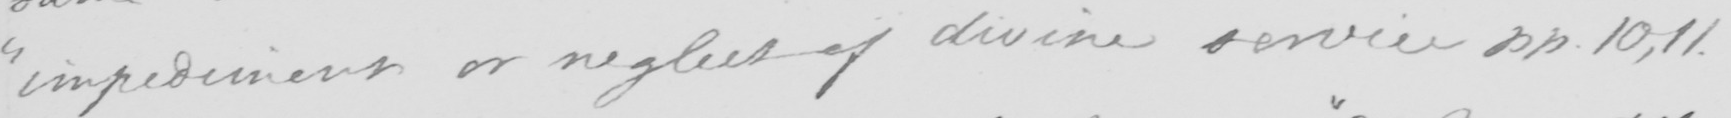Please transcribe the handwritten text in this image. " impediment or neglect of divine service pp 10,11 . 